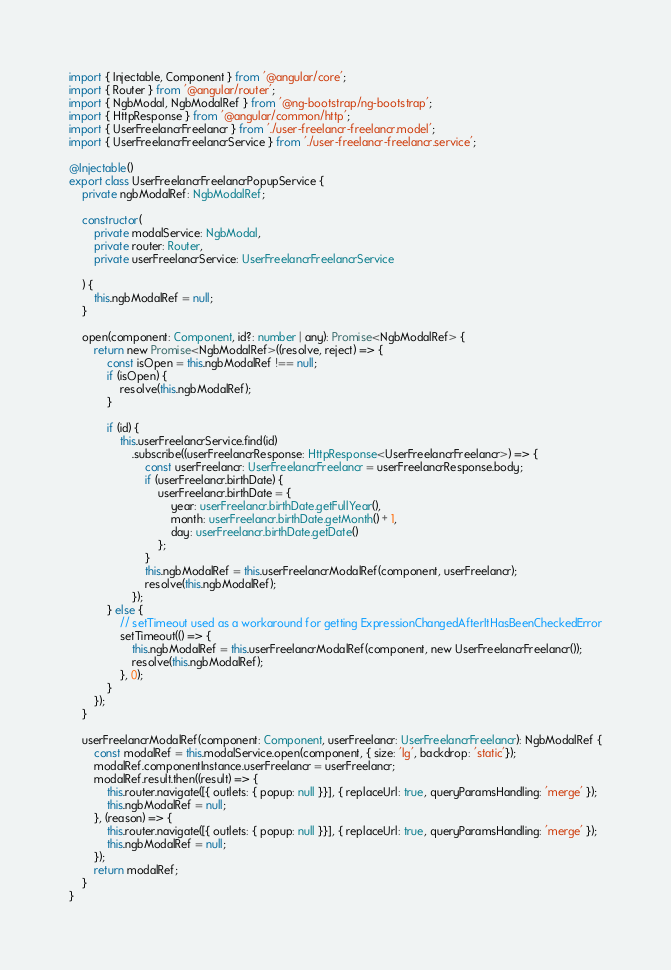Convert code to text. <code><loc_0><loc_0><loc_500><loc_500><_TypeScript_>import { Injectable, Component } from '@angular/core';
import { Router } from '@angular/router';
import { NgbModal, NgbModalRef } from '@ng-bootstrap/ng-bootstrap';
import { HttpResponse } from '@angular/common/http';
import { UserFreelancrFreelancr } from './user-freelancr-freelancr.model';
import { UserFreelancrFreelancrService } from './user-freelancr-freelancr.service';

@Injectable()
export class UserFreelancrFreelancrPopupService {
    private ngbModalRef: NgbModalRef;

    constructor(
        private modalService: NgbModal,
        private router: Router,
        private userFreelancrService: UserFreelancrFreelancrService

    ) {
        this.ngbModalRef = null;
    }

    open(component: Component, id?: number | any): Promise<NgbModalRef> {
        return new Promise<NgbModalRef>((resolve, reject) => {
            const isOpen = this.ngbModalRef !== null;
            if (isOpen) {
                resolve(this.ngbModalRef);
            }

            if (id) {
                this.userFreelancrService.find(id)
                    .subscribe((userFreelancrResponse: HttpResponse<UserFreelancrFreelancr>) => {
                        const userFreelancr: UserFreelancrFreelancr = userFreelancrResponse.body;
                        if (userFreelancr.birthDate) {
                            userFreelancr.birthDate = {
                                year: userFreelancr.birthDate.getFullYear(),
                                month: userFreelancr.birthDate.getMonth() + 1,
                                day: userFreelancr.birthDate.getDate()
                            };
                        }
                        this.ngbModalRef = this.userFreelancrModalRef(component, userFreelancr);
                        resolve(this.ngbModalRef);
                    });
            } else {
                // setTimeout used as a workaround for getting ExpressionChangedAfterItHasBeenCheckedError
                setTimeout(() => {
                    this.ngbModalRef = this.userFreelancrModalRef(component, new UserFreelancrFreelancr());
                    resolve(this.ngbModalRef);
                }, 0);
            }
        });
    }

    userFreelancrModalRef(component: Component, userFreelancr: UserFreelancrFreelancr): NgbModalRef {
        const modalRef = this.modalService.open(component, { size: 'lg', backdrop: 'static'});
        modalRef.componentInstance.userFreelancr = userFreelancr;
        modalRef.result.then((result) => {
            this.router.navigate([{ outlets: { popup: null }}], { replaceUrl: true, queryParamsHandling: 'merge' });
            this.ngbModalRef = null;
        }, (reason) => {
            this.router.navigate([{ outlets: { popup: null }}], { replaceUrl: true, queryParamsHandling: 'merge' });
            this.ngbModalRef = null;
        });
        return modalRef;
    }
}
</code> 